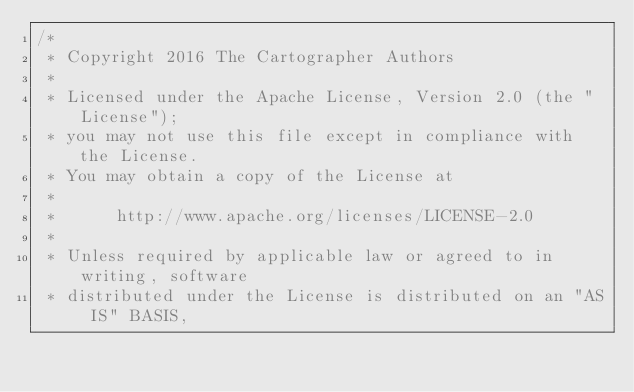<code> <loc_0><loc_0><loc_500><loc_500><_C_>/*
 * Copyright 2016 The Cartographer Authors
 *
 * Licensed under the Apache License, Version 2.0 (the "License");
 * you may not use this file except in compliance with the License.
 * You may obtain a copy of the License at
 *
 *      http://www.apache.org/licenses/LICENSE-2.0
 *
 * Unless required by applicable law or agreed to in writing, software
 * distributed under the License is distributed on an "AS IS" BASIS,</code> 